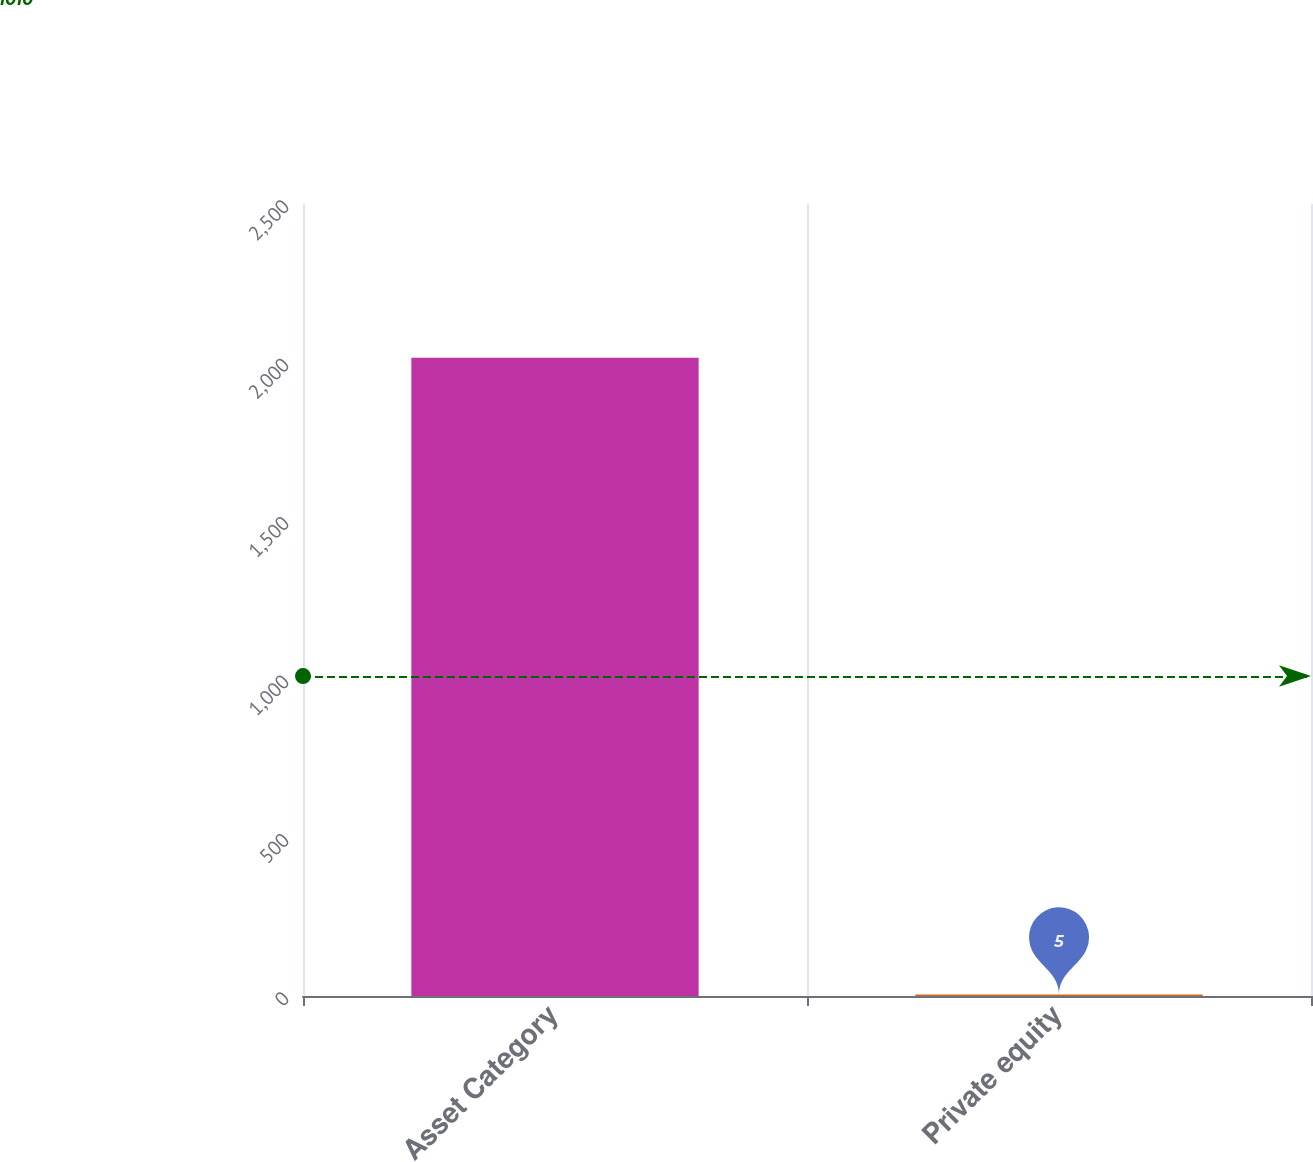<chart> <loc_0><loc_0><loc_500><loc_500><bar_chart><fcel>Asset Category<fcel>Private equity<nl><fcel>2015<fcel>5<nl></chart> 